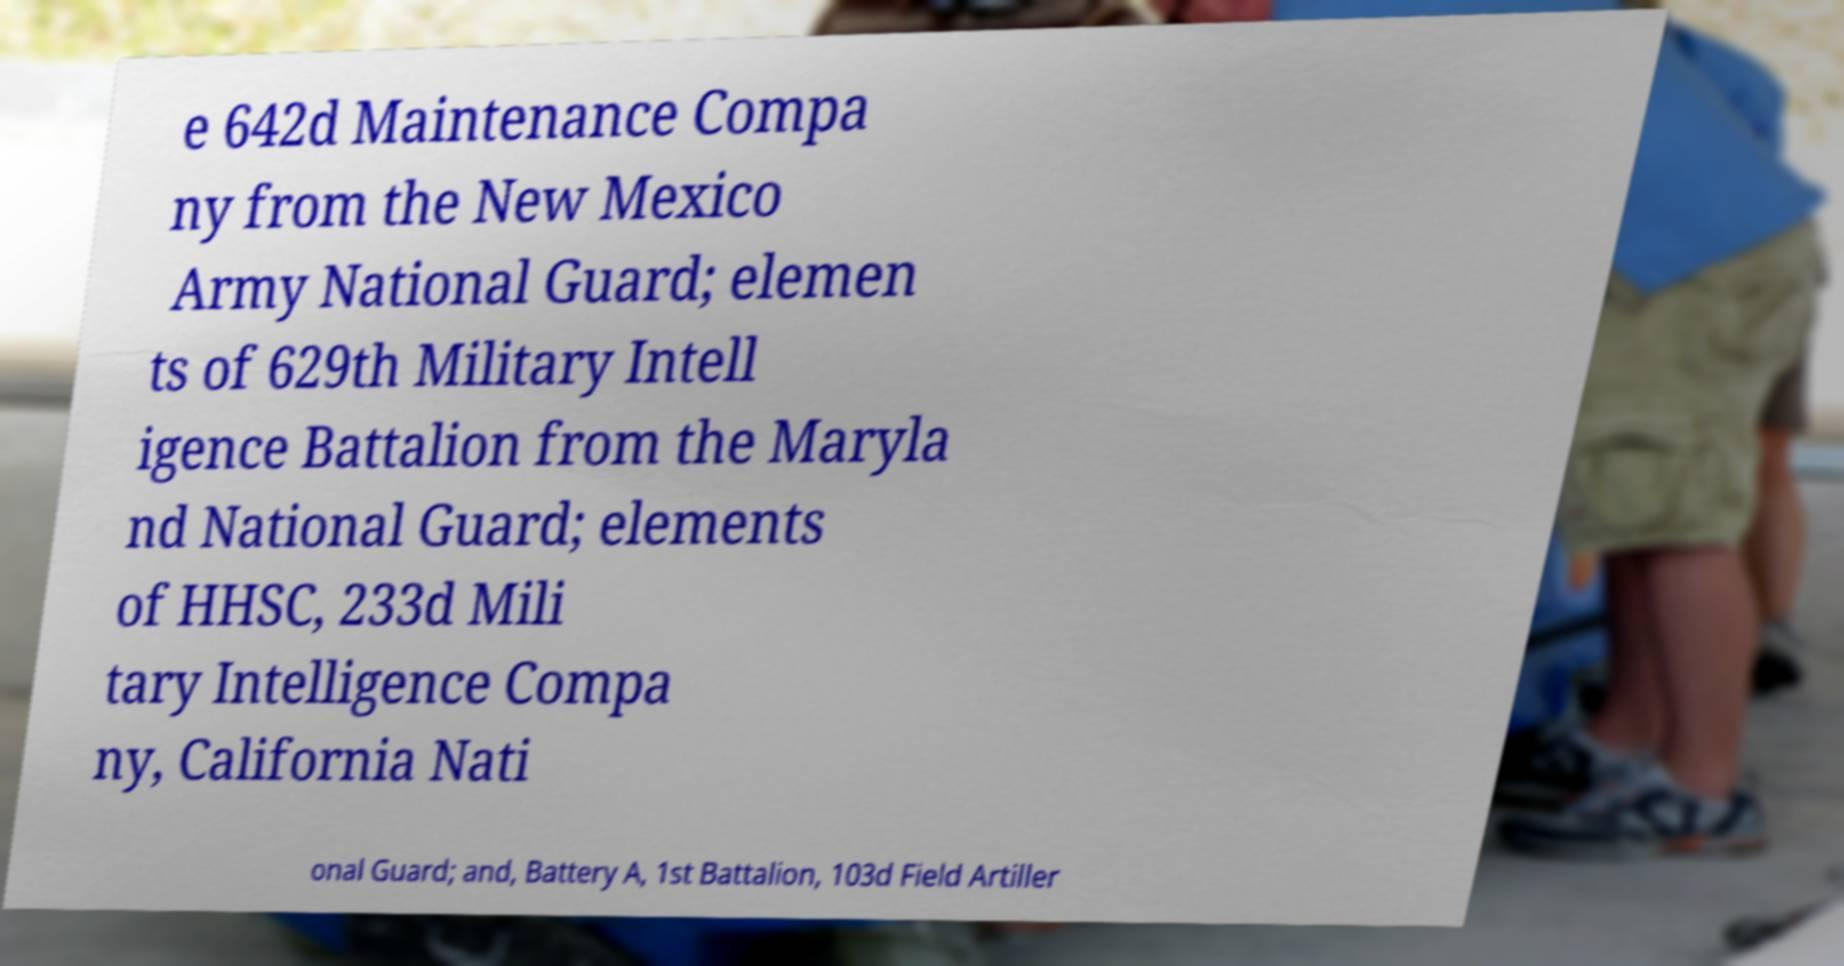Please identify and transcribe the text found in this image. e 642d Maintenance Compa ny from the New Mexico Army National Guard; elemen ts of 629th Military Intell igence Battalion from the Maryla nd National Guard; elements of HHSC, 233d Mili tary Intelligence Compa ny, California Nati onal Guard; and, Battery A, 1st Battalion, 103d Field Artiller 